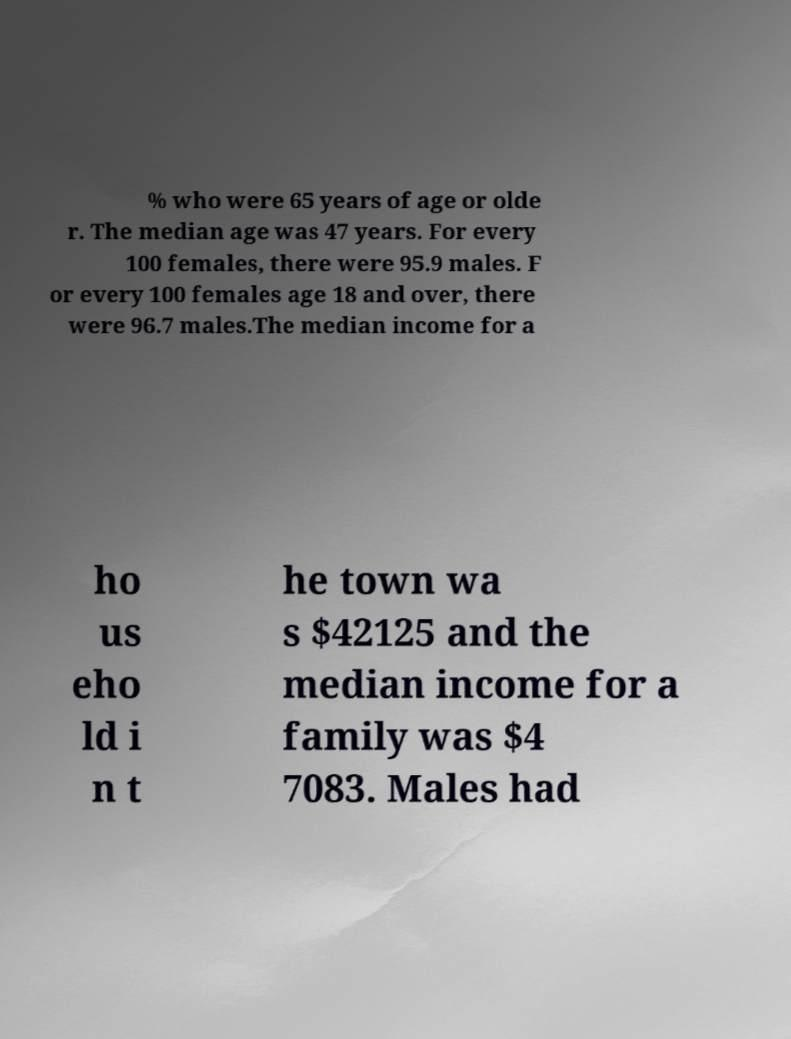Could you assist in decoding the text presented in this image and type it out clearly? % who were 65 years of age or olde r. The median age was 47 years. For every 100 females, there were 95.9 males. F or every 100 females age 18 and over, there were 96.7 males.The median income for a ho us eho ld i n t he town wa s $42125 and the median income for a family was $4 7083. Males had 